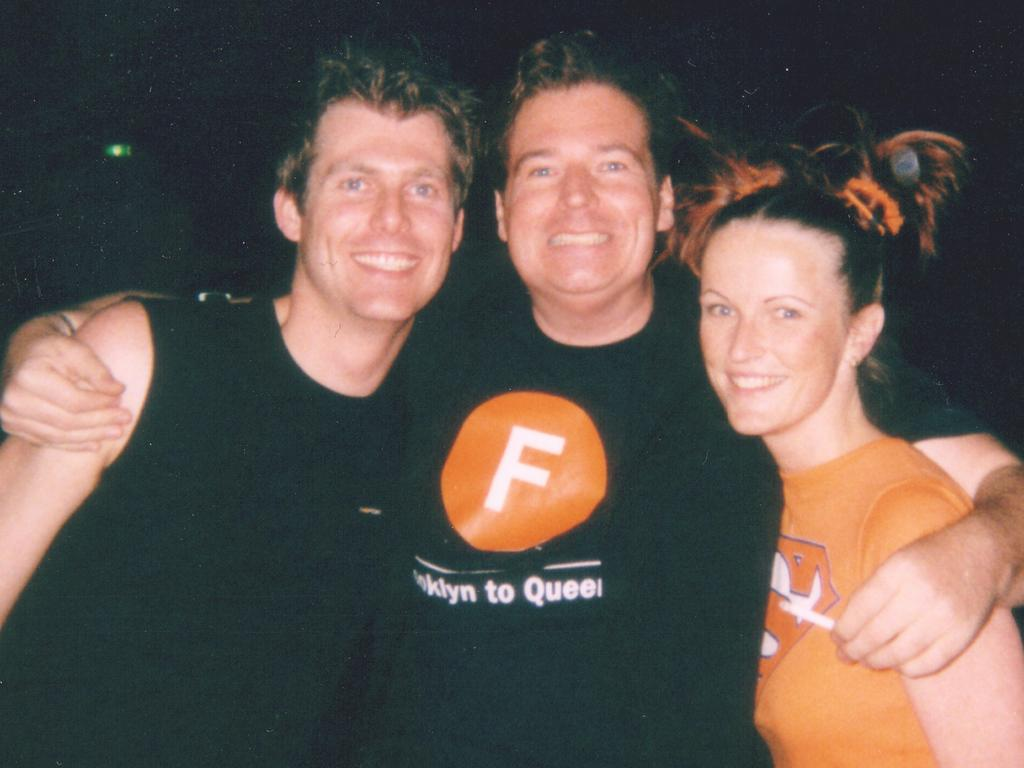How many people are in the image? There are three people in the image. What are the people doing in the image? The people are standing and smiling. What can be observed about the background of the image? The background of the image is dark. What type of nut can be seen falling from the sky in the image? There is no nut or any object falling from the sky in the image. Is there a volleyball game happening in the image? There is no volleyball game or any reference to a volleyball in the image. 